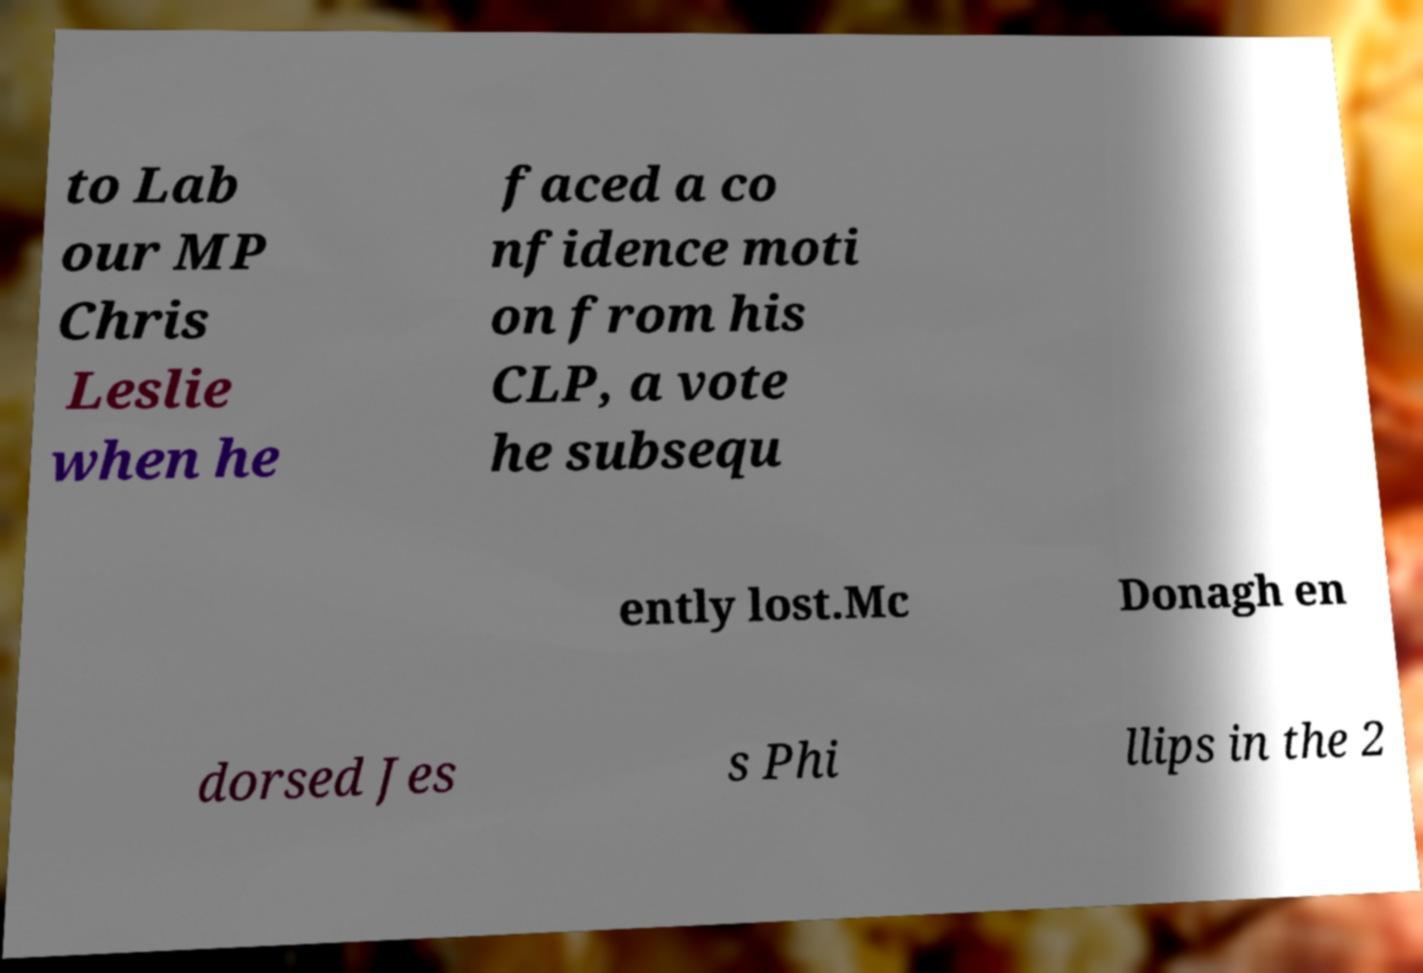Please read and relay the text visible in this image. What does it say? to Lab our MP Chris Leslie when he faced a co nfidence moti on from his CLP, a vote he subsequ ently lost.Mc Donagh en dorsed Jes s Phi llips in the 2 